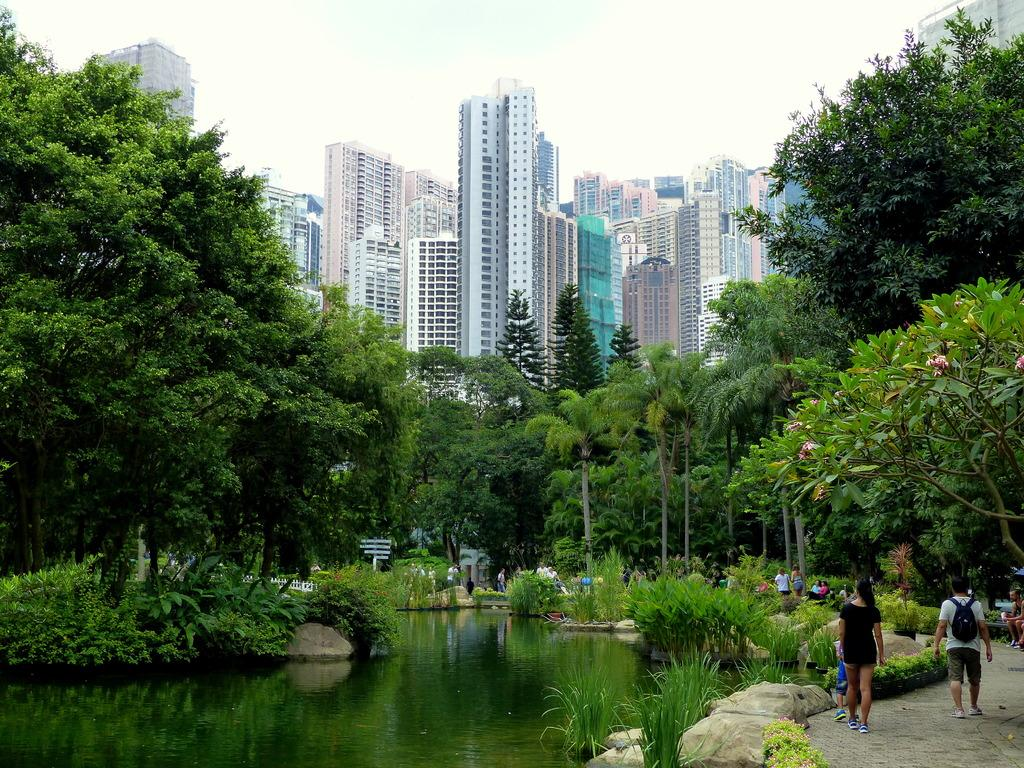What are the people in the image doing? The people in the image are walking. What type of natural elements can be seen in the image? Rocks, grass, plants, water, and trees are visible in the image. What man-made structures are present in the image? There is a fence and tower buildings in the image. What part of the natural environment is visible in the background of the image? The sky is visible in the background of the image. What type of toothpaste is being used by the people walking in the image? There is no toothpaste present in the image, as it features people walking in an outdoor environment. --- Facts: 1. There is a car in the image. 2. The car is red. 3. The car has four wheels. 4. There are people in the car. 5. The car has a sunroof. 6. The car is parked on the street. 7. There are trees on the side of the street. Absurd Topics: dance, rainbow, piano Conversation: What type of vehicle is in the image? There is a car in the image. What color is the car? The car is red. How many wheels does the car have? The car has four wheels. Who is inside the car? There are people in the car. What feature does the car have on its roof? The car has a sunroof. Where is the car located in the image? The car is parked on the street. What type of vegetation is visible on the side of the street? There are trees on the side of the street. Reasoning: Let's think step by step in order to produce the conversation. We start by identifying the main subject in the image, which is the car. Then, we expand the conversation to include other details about the car, such as its color, number of wheels, occupants, and sunroof. We also describe the car's location and the surrounding environment, including the presence of trees on the side of the street. Absurd Question/Answer: What type of dance is being performed by the people in the car in the image? There is no dance being performed in the image, as it features people sitting in a parked car. --- Facts: 1. There is a person holding a book in the image. 2. The book has a blue cover. 3. The person is sitting on a chair. 4. There is a table next to the chair. 5. The table has a lamp on it. 6. The room has a window. 7. The window has curtains. Absurd Topics: parrot, ocean, volcano Conversation: What is the person in the image holding? The person in the image is 